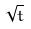<formula> <loc_0><loc_0><loc_500><loc_500>\sqrt { t }</formula> 